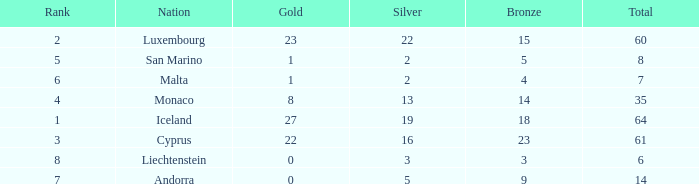Can you give me this table as a dict? {'header': ['Rank', 'Nation', 'Gold', 'Silver', 'Bronze', 'Total'], 'rows': [['2', 'Luxembourg', '23', '22', '15', '60'], ['5', 'San Marino', '1', '2', '5', '8'], ['6', 'Malta', '1', '2', '4', '7'], ['4', 'Monaco', '8', '13', '14', '35'], ['1', 'Iceland', '27', '19', '18', '64'], ['3', 'Cyprus', '22', '16', '23', '61'], ['8', 'Liechtenstein', '0', '3', '3', '6'], ['7', 'Andorra', '0', '5', '9', '14']]} How many golds for the nation with 14 total? 0.0. 